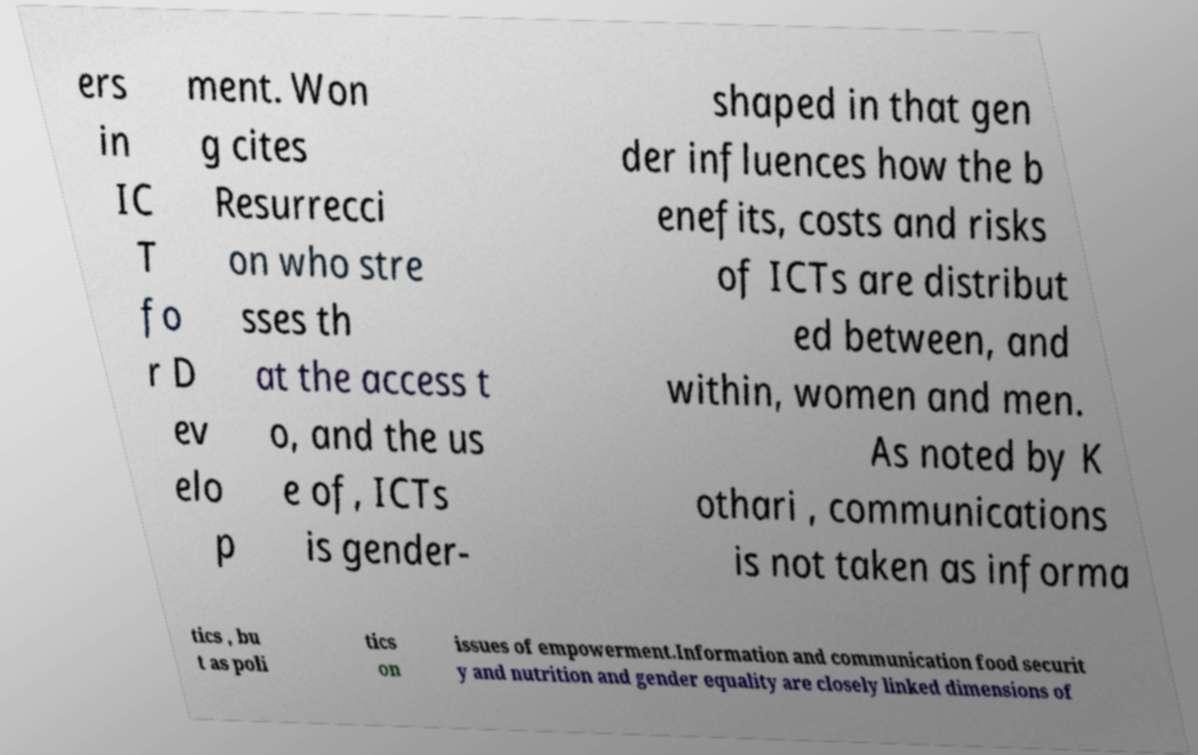What messages or text are displayed in this image? I need them in a readable, typed format. ers in IC T fo r D ev elo p ment. Won g cites Resurrecci on who stre sses th at the access t o, and the us e of, ICTs is gender- shaped in that gen der influences how the b enefits, costs and risks of ICTs are distribut ed between, and within, women and men. As noted by K othari , communications is not taken as informa tics , bu t as poli tics on issues of empowerment.Information and communication food securit y and nutrition and gender equality are closely linked dimensions of 